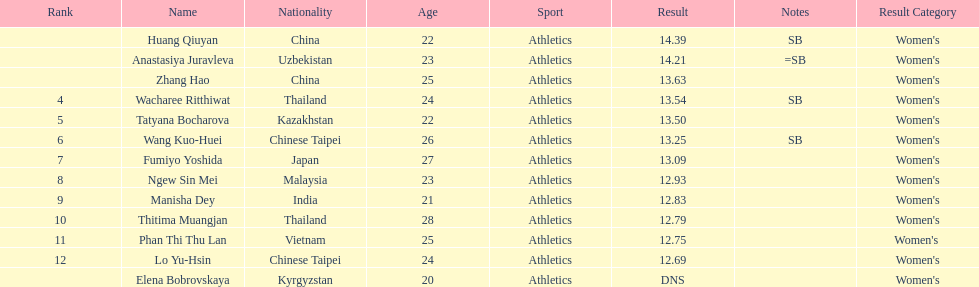How many points apart were the 1st place competitor and the 12th place competitor? 1.7. 